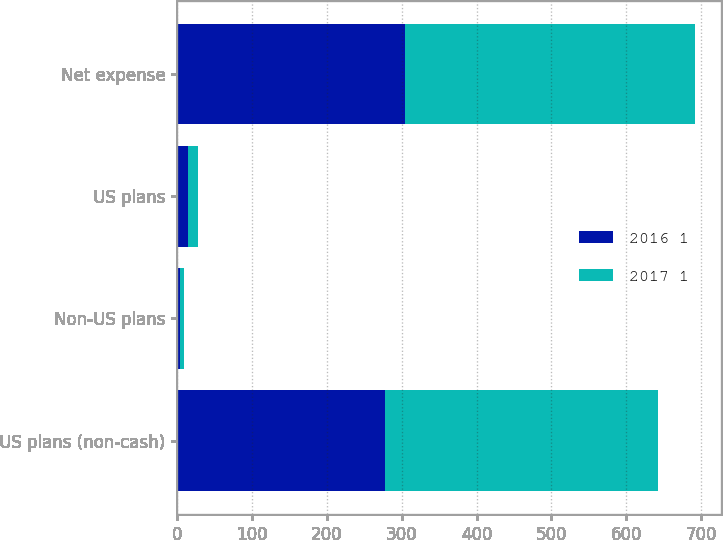<chart> <loc_0><loc_0><loc_500><loc_500><stacked_bar_chart><ecel><fcel>US plans (non-cash)<fcel>Non-US plans<fcel>US plans<fcel>Net expense<nl><fcel>2016 1<fcel>278<fcel>4<fcel>14<fcel>304<nl><fcel>2017 1<fcel>364<fcel>5<fcel>14<fcel>388<nl></chart> 